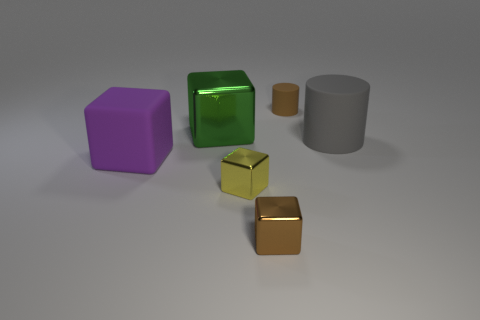Subtract all shiny cubes. How many cubes are left? 1 Add 1 tiny blue cylinders. How many objects exist? 7 Subtract all yellow cubes. How many cubes are left? 3 Subtract all cylinders. How many objects are left? 4 Subtract all red blocks. Subtract all green balls. How many blocks are left? 4 Add 2 cubes. How many cubes are left? 6 Add 6 small yellow blocks. How many small yellow blocks exist? 7 Subtract 1 green blocks. How many objects are left? 5 Subtract all tiny objects. Subtract all large metal blocks. How many objects are left? 2 